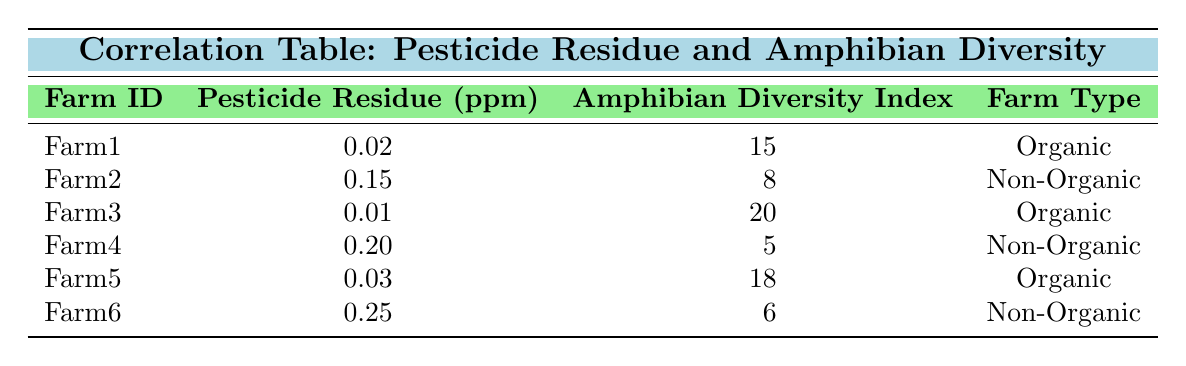What is the pesticide residue level for Farm3? According to the table, the pesticide residue level for Farm3 is listed directly in the corresponding row under the "Pesticide Residue (ppm)" column. It shows a value of 0.01 ppm.
Answer: 0.01 ppm Which farm has the highest amphibian diversity index? Looking at the "Amphibian Diversity Index" column, we note the values for each farm: Farm1 has 15, Farm2 has 8, Farm3 has 20, Farm4 has 5, Farm5 has 18, and Farm6 has 6. The highest value is 20, which corresponds to Farm3.
Answer: Farm3 Is there any farm in the data with a pesticide residue level greater than 0.2 ppm? In the table, the values listed for pesticide residue levels are 0.02, 0.15, 0.01, 0.20, 0.03, and 0.25 ppm. Only Farm6 has a residue level of 0.25 ppm, which is indeed greater than 0.2 ppm, making the answer true.
Answer: Yes What is the difference in amphibian diversity index between the organic farms and non-organic farms? First, we summarize the amphibian diversity for organic farms: Farm1 has 15, Farm3 has 20, and Farm5 has 18. The average for organic farms is (15 + 20 + 18) / 3 = 17.67. For non-organic farms: Farm2 has 8, Farm4 has 5, and Farm6 has 6. The average for non-organic farms is (8 + 5 + 6) / 3 = 6.33. The difference is 17.67 - 6.33 = 11.34.
Answer: 11.34 How many organic farms have a pesticide residue level below 0.1 ppm? The organic farms are Farm1, Farm3, and Farm5. Their pesticide residue levels are 0.02, 0.01, and 0.03 ppm respectively. All three of these values are below 0.1 ppm. Thus, the count of organic farms with residue levels below this threshold is three.
Answer: 3 